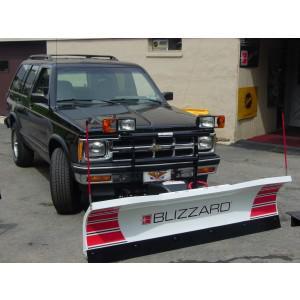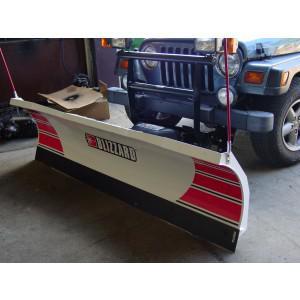The first image is the image on the left, the second image is the image on the right. For the images shown, is this caption "Snow is being cleared by a vehicle." true? Answer yes or no. No. The first image is the image on the left, the second image is the image on the right. Evaluate the accuracy of this statement regarding the images: "One image shows a vehicle pushing a plow through snow.". Is it true? Answer yes or no. No. 